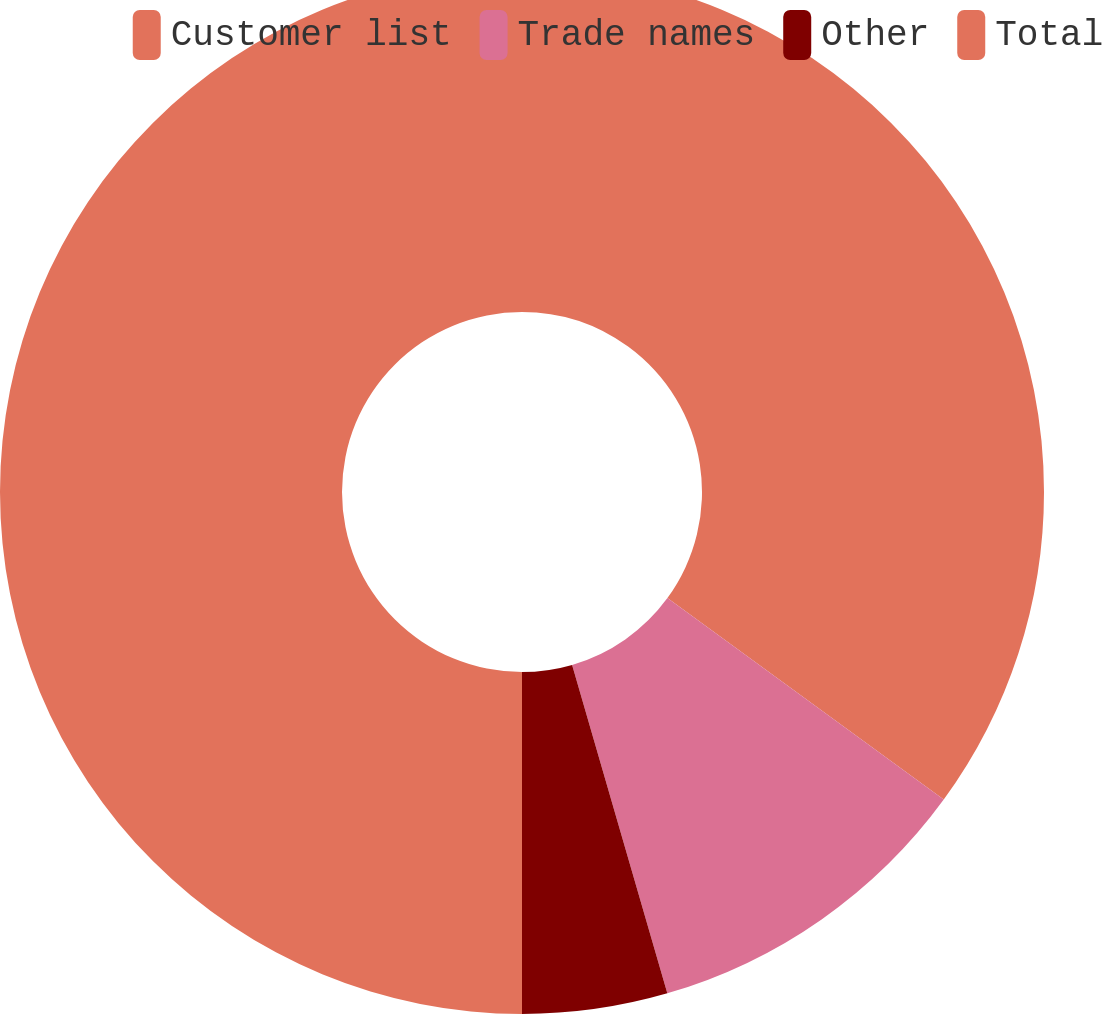<chart> <loc_0><loc_0><loc_500><loc_500><pie_chart><fcel>Customer list<fcel>Trade names<fcel>Other<fcel>Total<nl><fcel>35.03%<fcel>10.48%<fcel>4.49%<fcel>50.0%<nl></chart> 